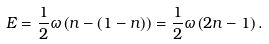<formula> <loc_0><loc_0><loc_500><loc_500>E = \frac { 1 } { 2 } \omega \left ( n - ( 1 - n ) \right ) = \frac { 1 } { 2 } \omega \left ( 2 n - 1 \right ) .</formula> 